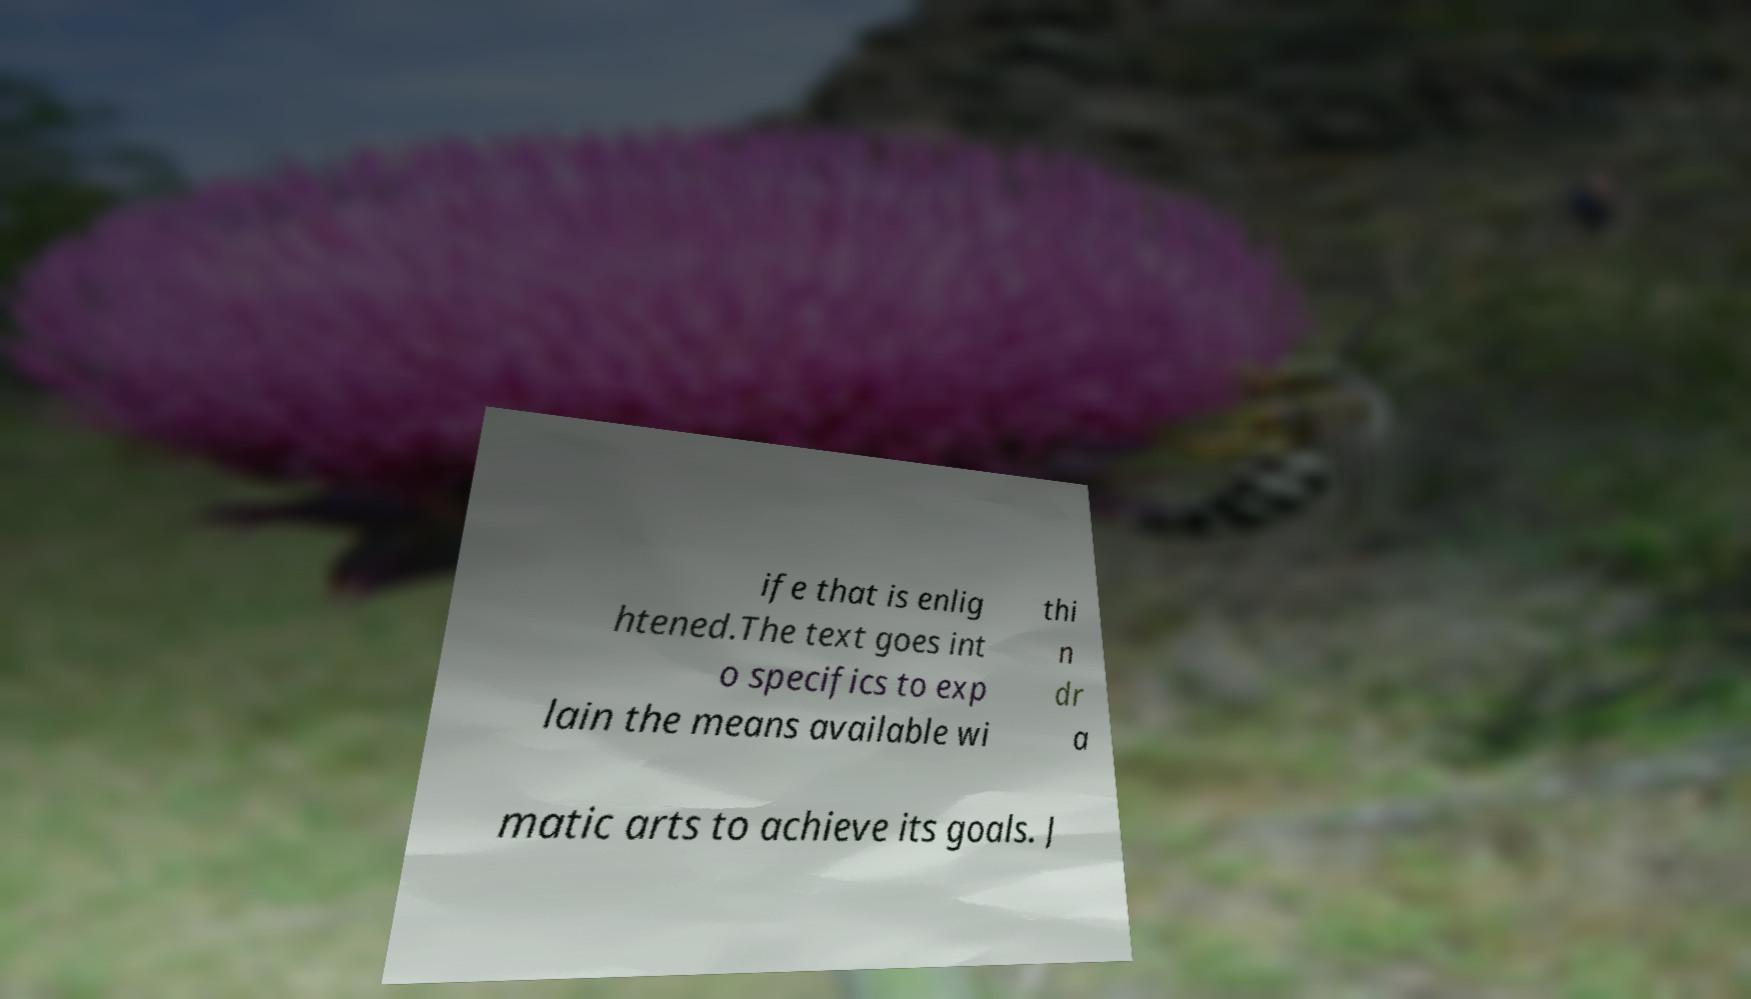Please identify and transcribe the text found in this image. ife that is enlig htened.The text goes int o specifics to exp lain the means available wi thi n dr a matic arts to achieve its goals. J 